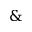Convert formula to latex. <formula><loc_0><loc_0><loc_500><loc_500>\&</formula> 